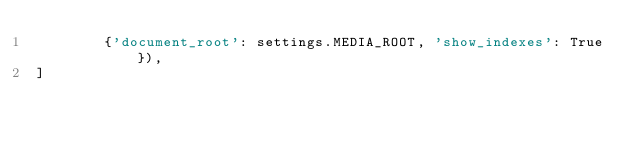<code> <loc_0><loc_0><loc_500><loc_500><_Python_>        {'document_root': settings.MEDIA_ROOT, 'show_indexes': True}),
]
</code> 